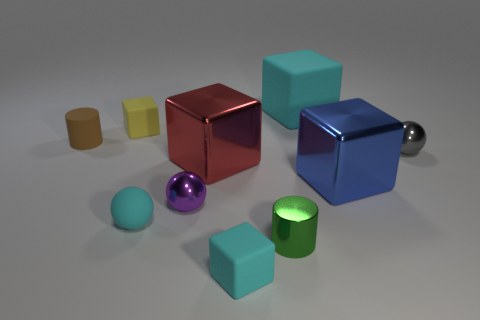How does the lighting in this image affect the appearance of the objects? The lighting casts subtle shadows and highlights the objects' reflective properties, creating an interplay of light and texture that gives each object depth and a three-dimensional appearance. 